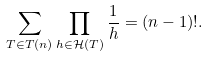<formula> <loc_0><loc_0><loc_500><loc_500>\sum _ { T \in T ( n ) } \prod _ { h \in \mathcal { H } ( T ) } { \frac { 1 } { h } } = ( n - 1 ) ! .</formula> 